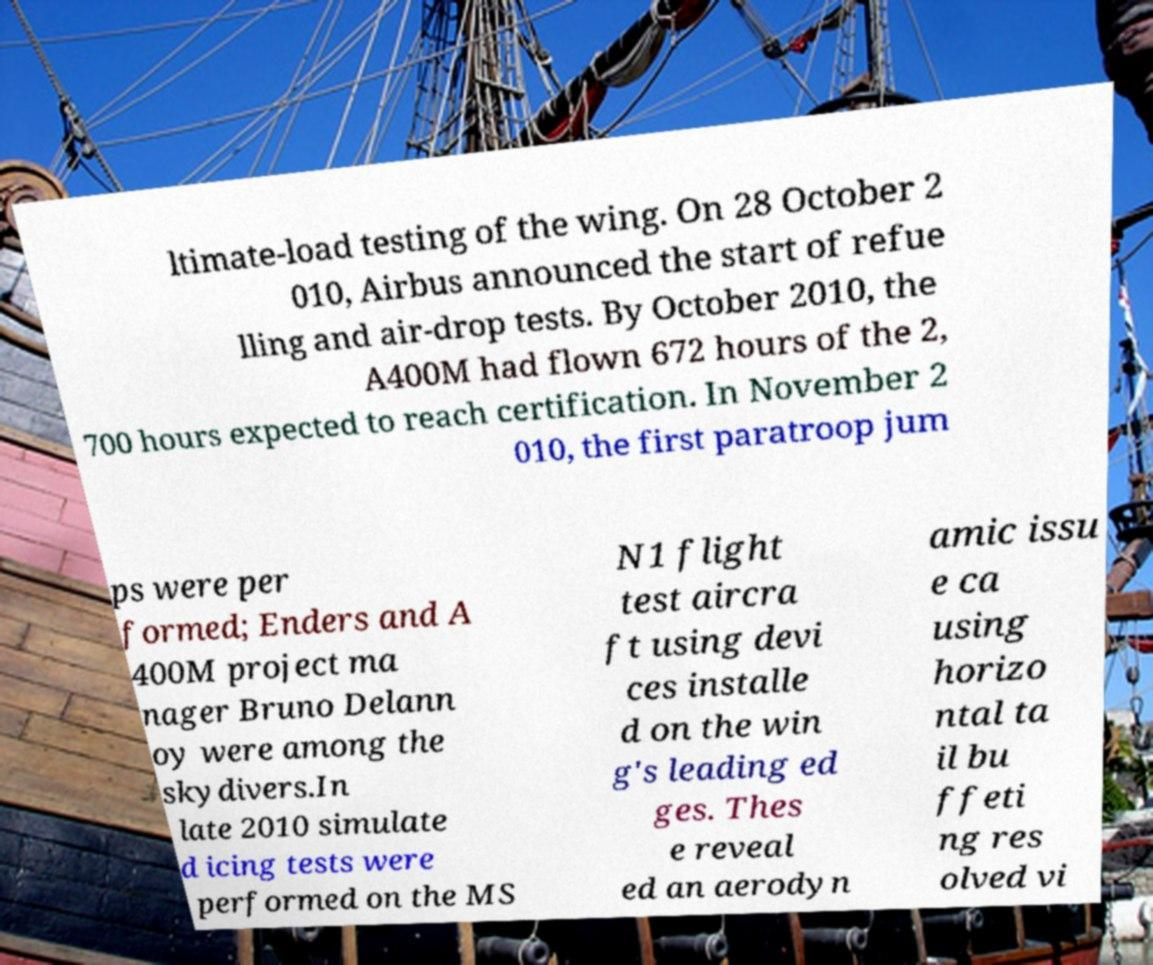For documentation purposes, I need the text within this image transcribed. Could you provide that? ltimate-load testing of the wing. On 28 October 2 010, Airbus announced the start of refue lling and air-drop tests. By October 2010, the A400M had flown 672 hours of the 2, 700 hours expected to reach certification. In November 2 010, the first paratroop jum ps were per formed; Enders and A 400M project ma nager Bruno Delann oy were among the skydivers.In late 2010 simulate d icing tests were performed on the MS N1 flight test aircra ft using devi ces installe d on the win g's leading ed ges. Thes e reveal ed an aerodyn amic issu e ca using horizo ntal ta il bu ffeti ng res olved vi 